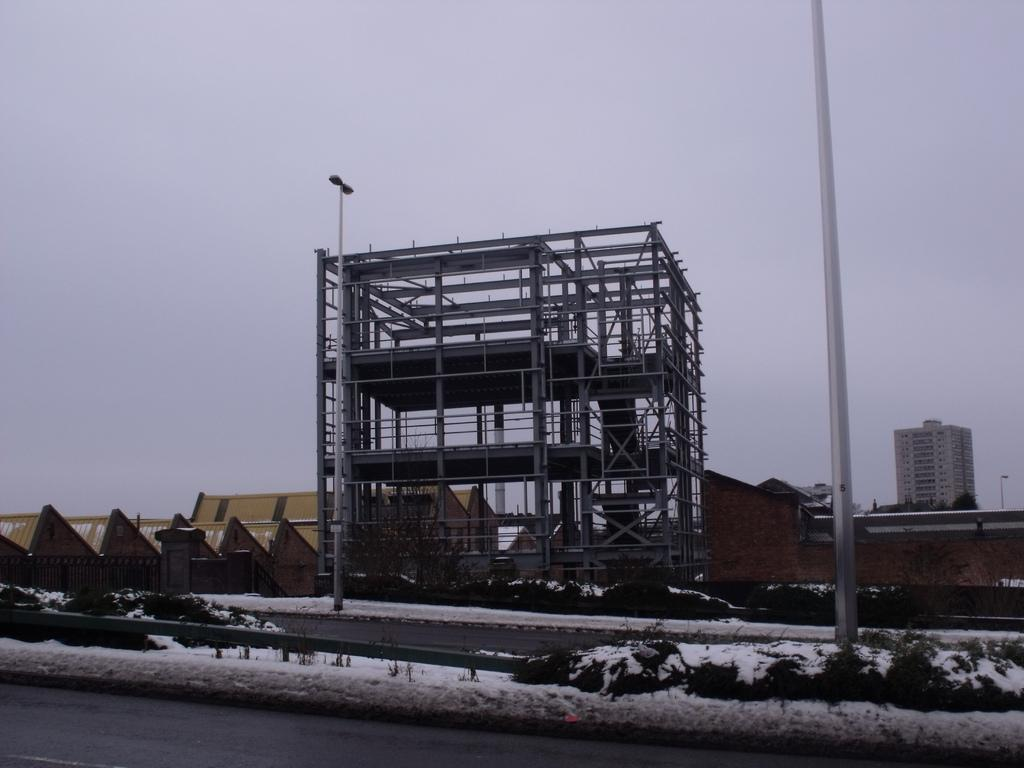What is the main feature of the image? There is a road in the image. What else can be seen in the image besides the road? There is an under-construction building and pyramid-shaped buildings in the image. What type of toys are being used to increase the fuel efficiency of the under-construction building in the image? There are no toys or fuel efficiency concerns mentioned in the image; it features a road, an under-construction building, and pyramid-shaped buildings. 